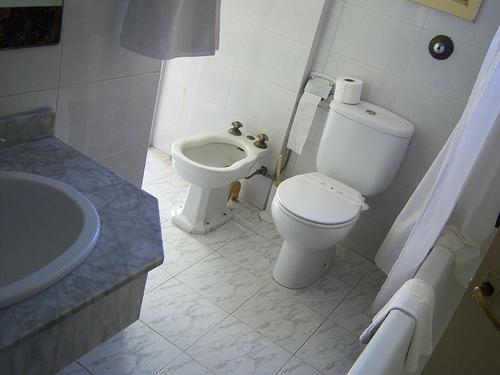Why is the toilet paper on top of the toilet?

Choices:
A) easy access
B) reduce noise
C) safety
D) aesthetics easy access 